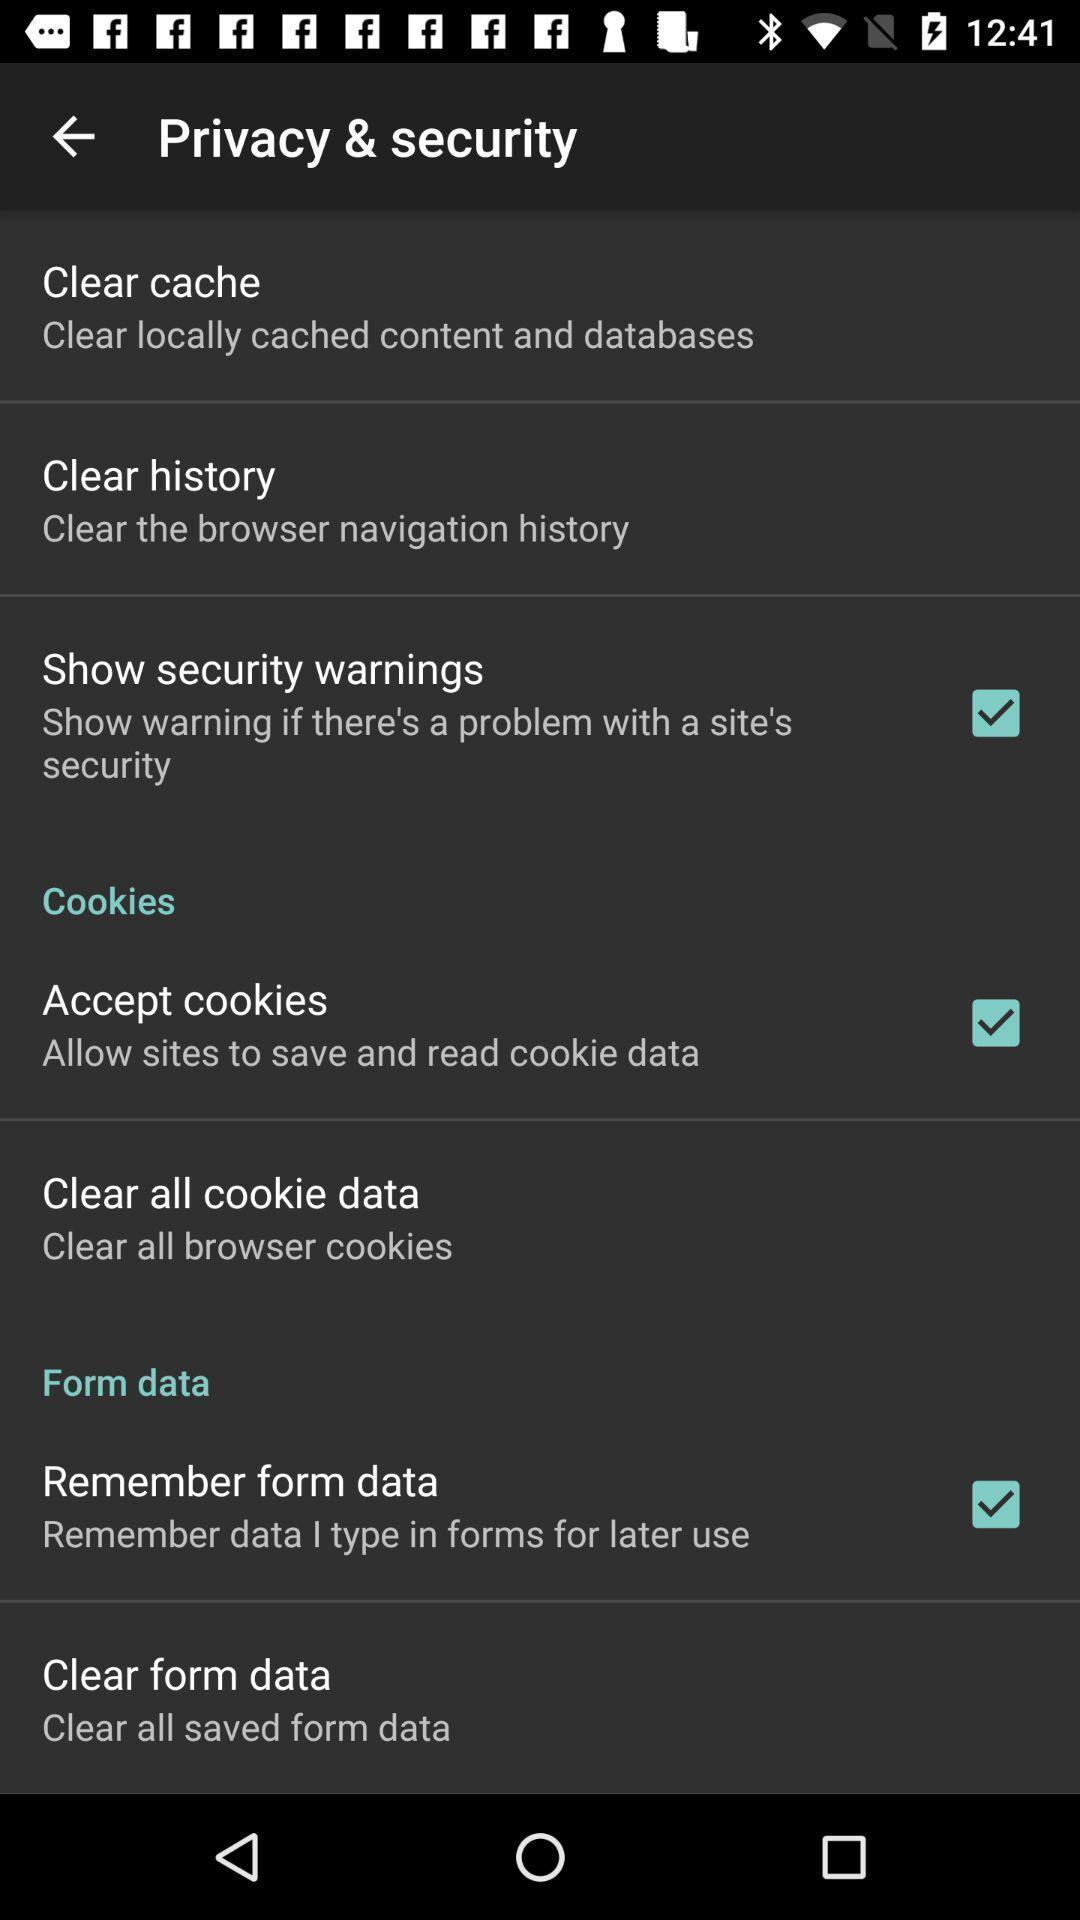Describe the content in this image. Page displaying different options and settings in privacy option. 